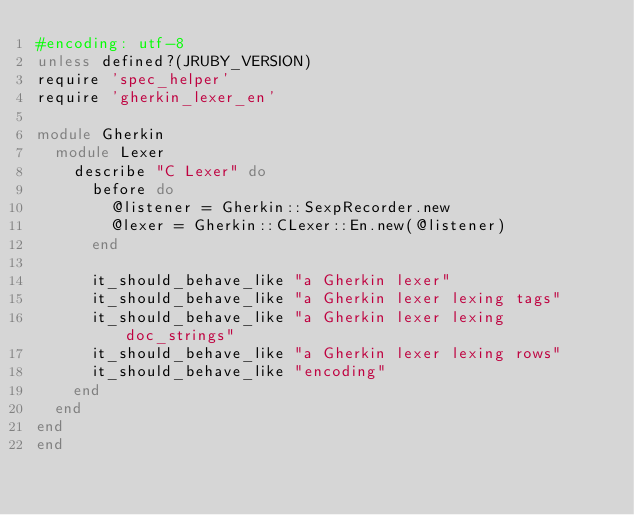Convert code to text. <code><loc_0><loc_0><loc_500><loc_500><_Ruby_>#encoding: utf-8
unless defined?(JRUBY_VERSION)
require 'spec_helper'
require 'gherkin_lexer_en'

module Gherkin
  module Lexer
    describe "C Lexer" do
      before do
        @listener = Gherkin::SexpRecorder.new
        @lexer = Gherkin::CLexer::En.new(@listener)
      end

      it_should_behave_like "a Gherkin lexer"
      it_should_behave_like "a Gherkin lexer lexing tags"
      it_should_behave_like "a Gherkin lexer lexing doc_strings"
      it_should_behave_like "a Gherkin lexer lexing rows"
      it_should_behave_like "encoding"
    end
  end
end
end
</code> 